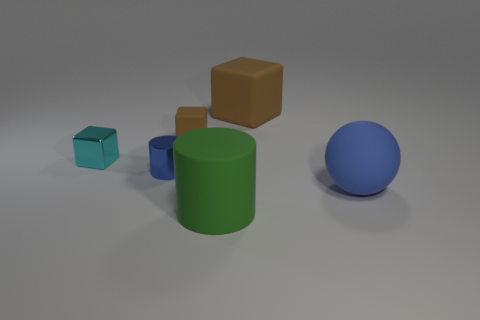What size is the rubber object that is the same color as the big cube?
Your response must be concise. Small. What number of objects are either large objects or big green metallic cylinders?
Make the answer very short. 3. How many other things are the same size as the matte cylinder?
Ensure brevity in your answer.  2. Do the tiny cylinder and the metallic block behind the big green cylinder have the same color?
Keep it short and to the point. No. What number of cylinders are large brown objects or blue metal objects?
Ensure brevity in your answer.  1. Is there any other thing that is the same color as the large matte cube?
Give a very brief answer. Yes. There is a big thing behind the brown cube in front of the big rubber cube; what is it made of?
Offer a very short reply. Rubber. Do the large blue object and the tiny thing that is behind the cyan object have the same material?
Your answer should be very brief. Yes. How many things are brown blocks behind the tiny metal cylinder or matte balls?
Offer a terse response. 3. Are there any large shiny objects that have the same color as the large ball?
Ensure brevity in your answer.  No. 